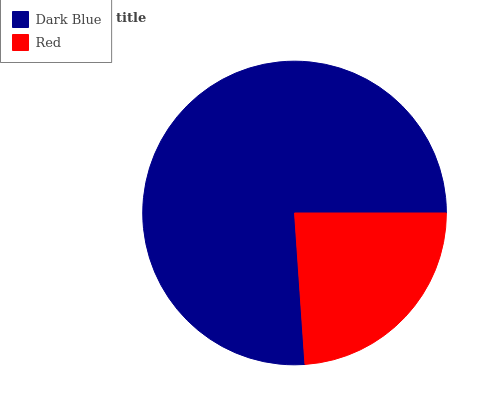Is Red the minimum?
Answer yes or no. Yes. Is Dark Blue the maximum?
Answer yes or no. Yes. Is Red the maximum?
Answer yes or no. No. Is Dark Blue greater than Red?
Answer yes or no. Yes. Is Red less than Dark Blue?
Answer yes or no. Yes. Is Red greater than Dark Blue?
Answer yes or no. No. Is Dark Blue less than Red?
Answer yes or no. No. Is Dark Blue the high median?
Answer yes or no. Yes. Is Red the low median?
Answer yes or no. Yes. Is Red the high median?
Answer yes or no. No. Is Dark Blue the low median?
Answer yes or no. No. 